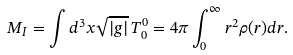Convert formula to latex. <formula><loc_0><loc_0><loc_500><loc_500>M _ { I } = \int d ^ { 3 } x \sqrt { | g | } \, T ^ { 0 } _ { 0 } = 4 \pi \int _ { 0 } ^ { \infty } r ^ { 2 } \rho ( r ) d r .</formula> 